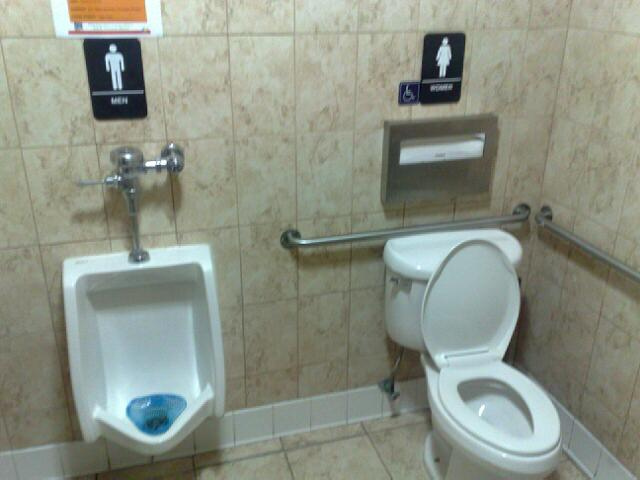Read and extract the text from this image. MEN WOMEN 